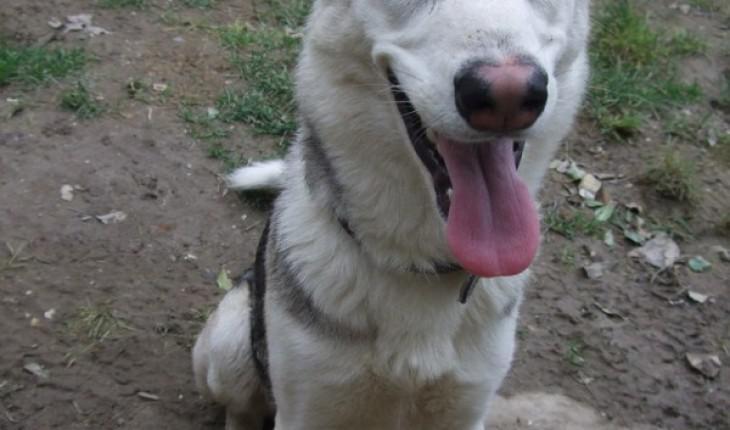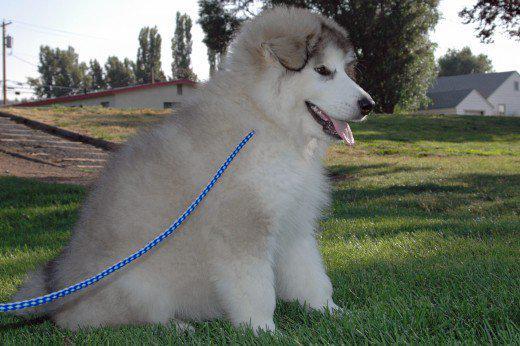The first image is the image on the left, the second image is the image on the right. Given the left and right images, does the statement "A dog is standing next to a person." hold true? Answer yes or no. No. The first image is the image on the left, the second image is the image on the right. Analyze the images presented: Is the assertion "The left and right image contains the same number of dogs." valid? Answer yes or no. Yes. 